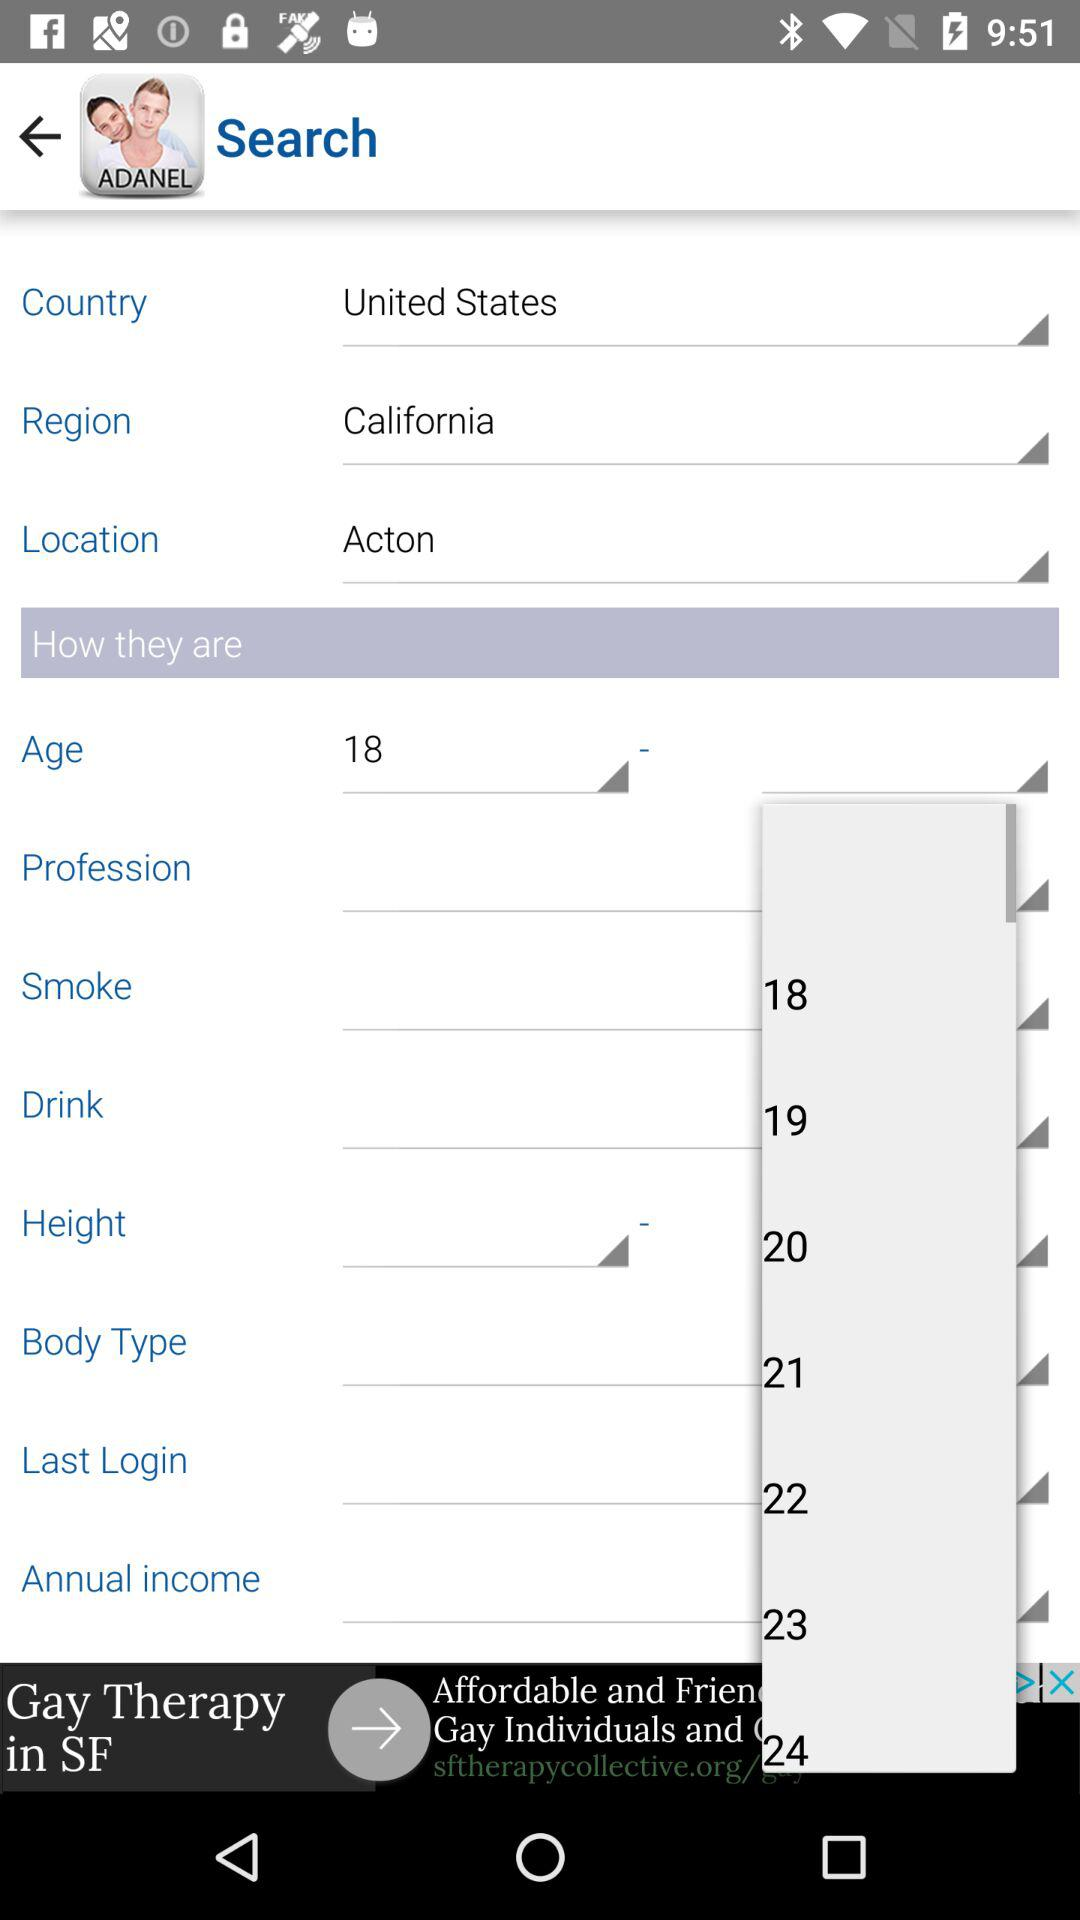What is the location? The location is Acton. 